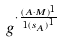Convert formula to latex. <formula><loc_0><loc_0><loc_500><loc_500>g ^ { \cdot \frac { ( A \cdot M ) ^ { 1 } } { 1 { ( s _ { A } ) } ^ { 1 } } }</formula> 